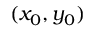Convert formula to latex. <formula><loc_0><loc_0><loc_500><loc_500>( x _ { 0 } , y _ { 0 } )</formula> 